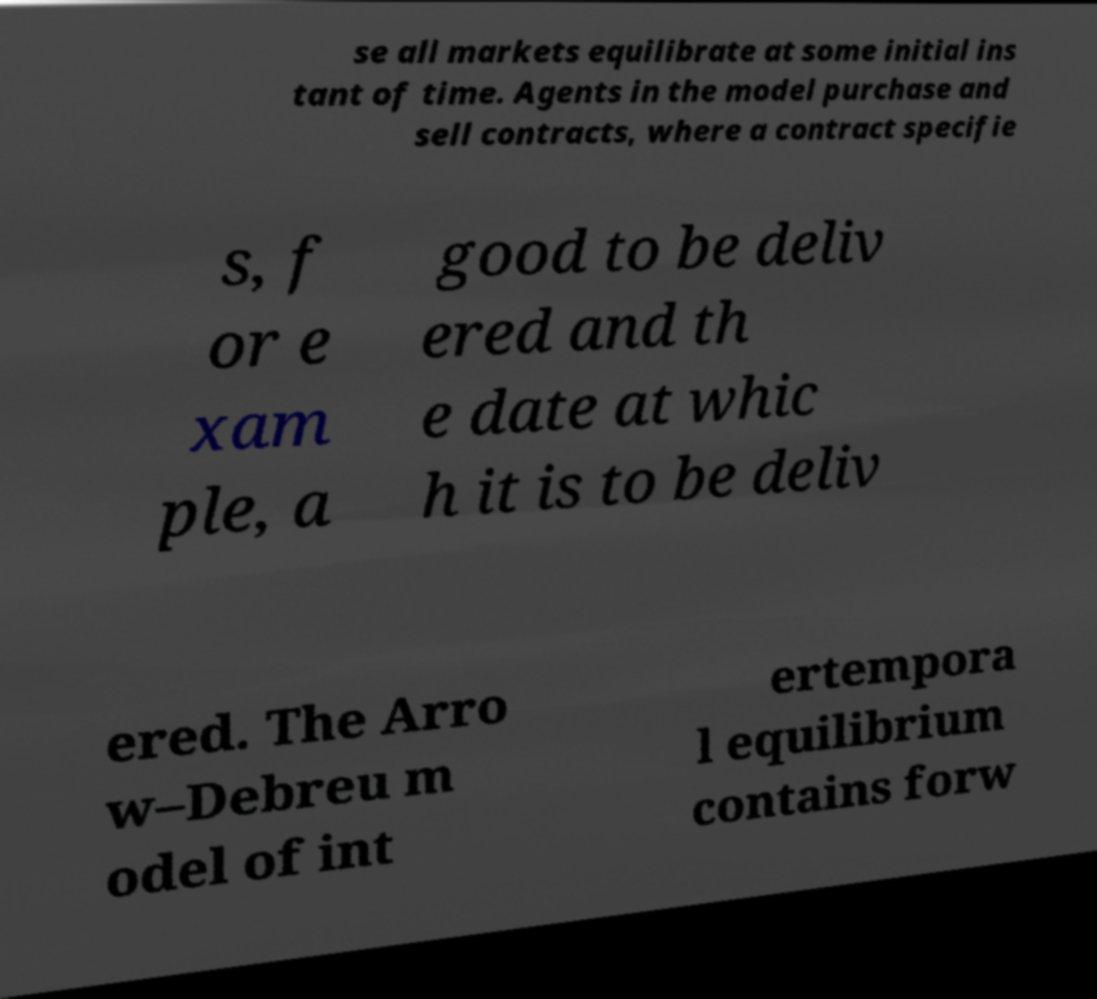Could you extract and type out the text from this image? se all markets equilibrate at some initial ins tant of time. Agents in the model purchase and sell contracts, where a contract specifie s, f or e xam ple, a good to be deliv ered and th e date at whic h it is to be deliv ered. The Arro w–Debreu m odel of int ertempora l equilibrium contains forw 